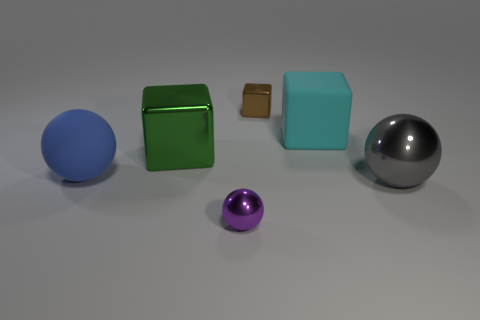What number of other green things have the same size as the green thing?
Offer a very short reply. 0. There is a large metallic thing that is behind the matte sphere; are there any blue matte things that are on the right side of it?
Your answer should be compact. No. How many objects are tiny matte spheres or brown shiny cubes?
Offer a terse response. 1. The object that is on the left side of the large cube in front of the large block on the right side of the large green cube is what color?
Provide a succinct answer. Blue. Is there anything else of the same color as the rubber ball?
Provide a succinct answer. No. Is the size of the purple ball the same as the green metallic object?
Your response must be concise. No. How many objects are either large blue matte things that are in front of the brown metallic block or tiny things that are behind the big cyan rubber object?
Keep it short and to the point. 2. What is the small thing behind the big rubber object that is on the left side of the small brown cube made of?
Your answer should be compact. Metal. How many other things are made of the same material as the small brown cube?
Offer a terse response. 3. Is the large green metal thing the same shape as the big gray object?
Keep it short and to the point. No. 